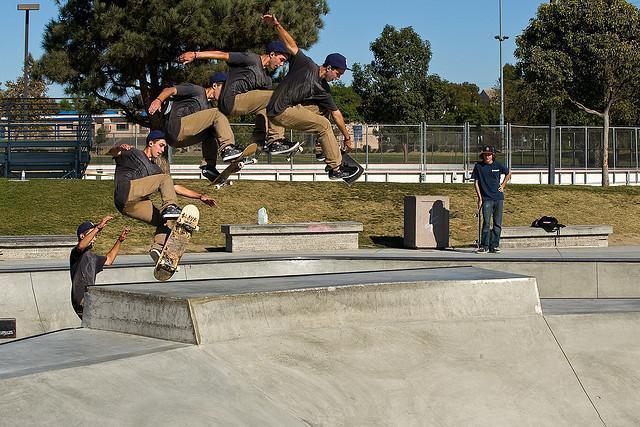How many people wearing tan pants and black shirts are seen here?
Answer the question by selecting the correct answer among the 4 following choices.
Options: Two, five, one, six. One. 